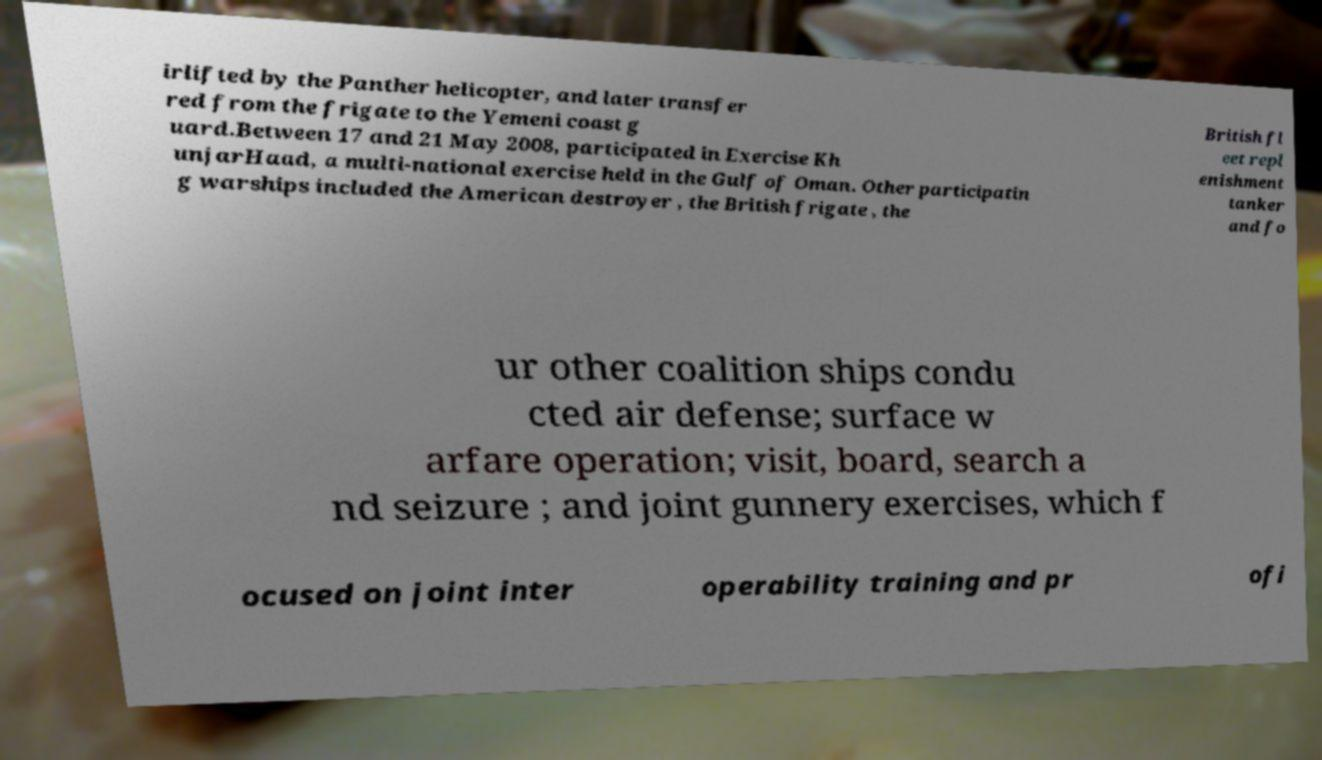Could you assist in decoding the text presented in this image and type it out clearly? irlifted by the Panther helicopter, and later transfer red from the frigate to the Yemeni coast g uard.Between 17 and 21 May 2008, participated in Exercise Kh unjarHaad, a multi-national exercise held in the Gulf of Oman. Other participatin g warships included the American destroyer , the British frigate , the British fl eet repl enishment tanker and fo ur other coalition ships condu cted air defense; surface w arfare operation; visit, board, search a nd seizure ; and joint gunnery exercises, which f ocused on joint inter operability training and pr ofi 